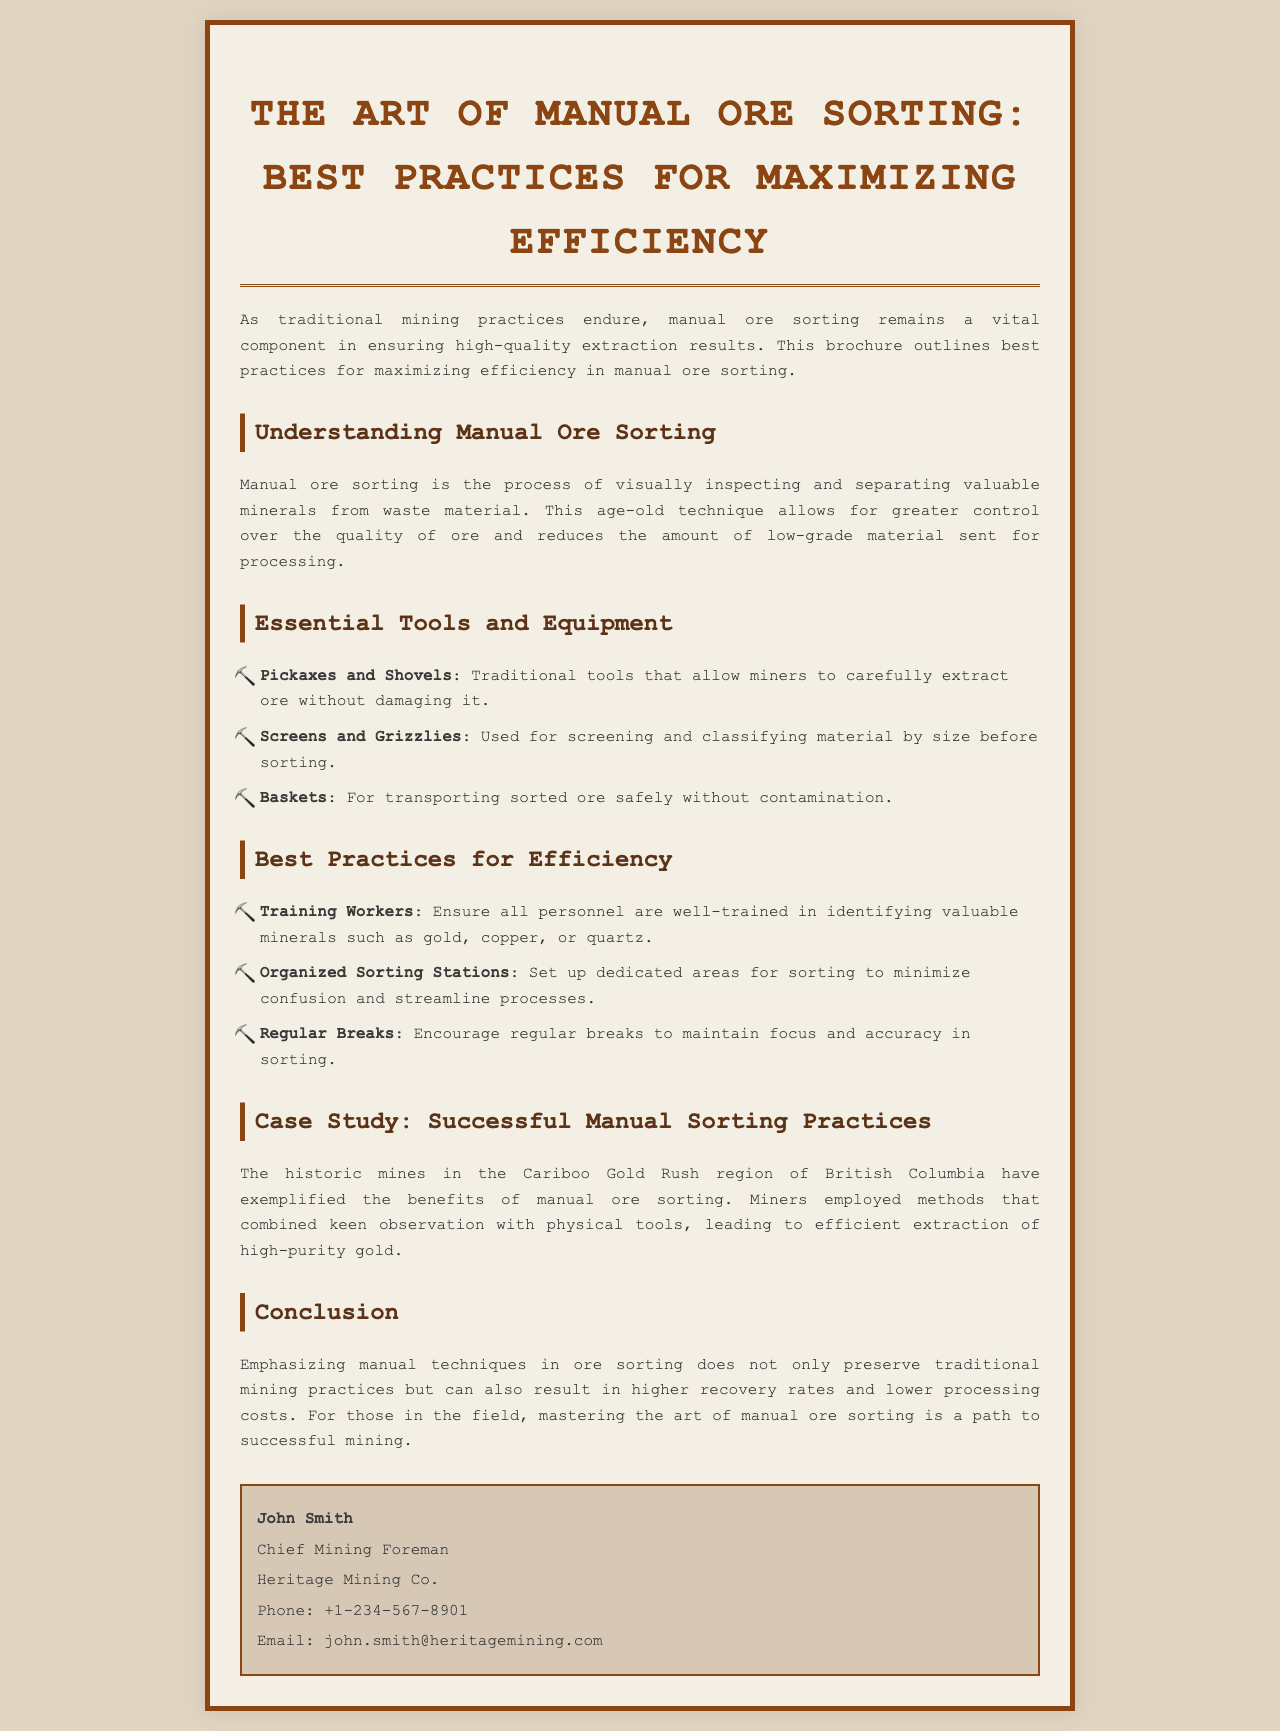what is the title of the brochure? The title of the brochure is prominently displayed at the top of the document.
Answer: The Art of Manual Ore Sorting: Best Practices for Maximizing Efficiency who is the Chief Mining Foreman mentioned in the document? The document includes contact information for the Chief Mining Foreman.
Answer: John Smith what is one essential tool for manual ore sorting? The document lists various tools essential for manual ore sorting.
Answer: Pickaxes and Shovels how many best practices for efficiency are listed in the brochure? The brochure outlines several best practices under a specific section.
Answer: Three what legendary mining region is mentioned as a successful example of manual sorting? The case study highlights a specific historical mining region.
Answer: Cariboo Gold Rush what is one benefit of emphasizing manual techniques in ore sorting? The conclusion of the document mentions a key advantage of manual ore sorting.
Answer: Higher recovery rates what does the brochure suggest to maintain focus in sorting? The document includes a recommendation aimed at improving sorting efficiency.
Answer: Regular Breaks 